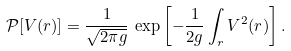Convert formula to latex. <formula><loc_0><loc_0><loc_500><loc_500>\mathcal { P } [ V ( r ) ] = \frac { 1 } { \sqrt { 2 \pi g } } \, \exp \left [ - \frac { 1 } { 2 g } \int _ { r } V ^ { 2 } ( r ) \right ] .</formula> 